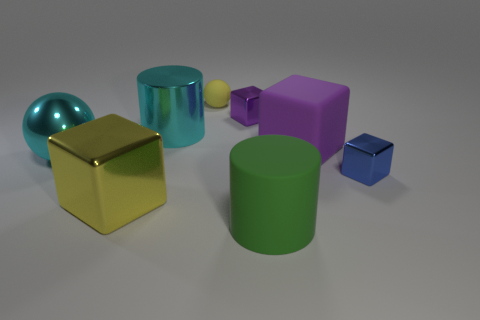Subtract all large metal blocks. How many blocks are left? 3 Subtract all green cylinders. How many cylinders are left? 1 Add 2 big cyan shiny cylinders. How many objects exist? 10 Subtract all balls. How many objects are left? 6 Subtract 1 cubes. How many cubes are left? 3 Subtract all green blocks. Subtract all green cylinders. How many blocks are left? 4 Subtract all yellow blocks. How many yellow spheres are left? 1 Subtract all purple metal blocks. Subtract all small blue metal blocks. How many objects are left? 6 Add 4 yellow spheres. How many yellow spheres are left? 5 Add 6 yellow metal balls. How many yellow metal balls exist? 6 